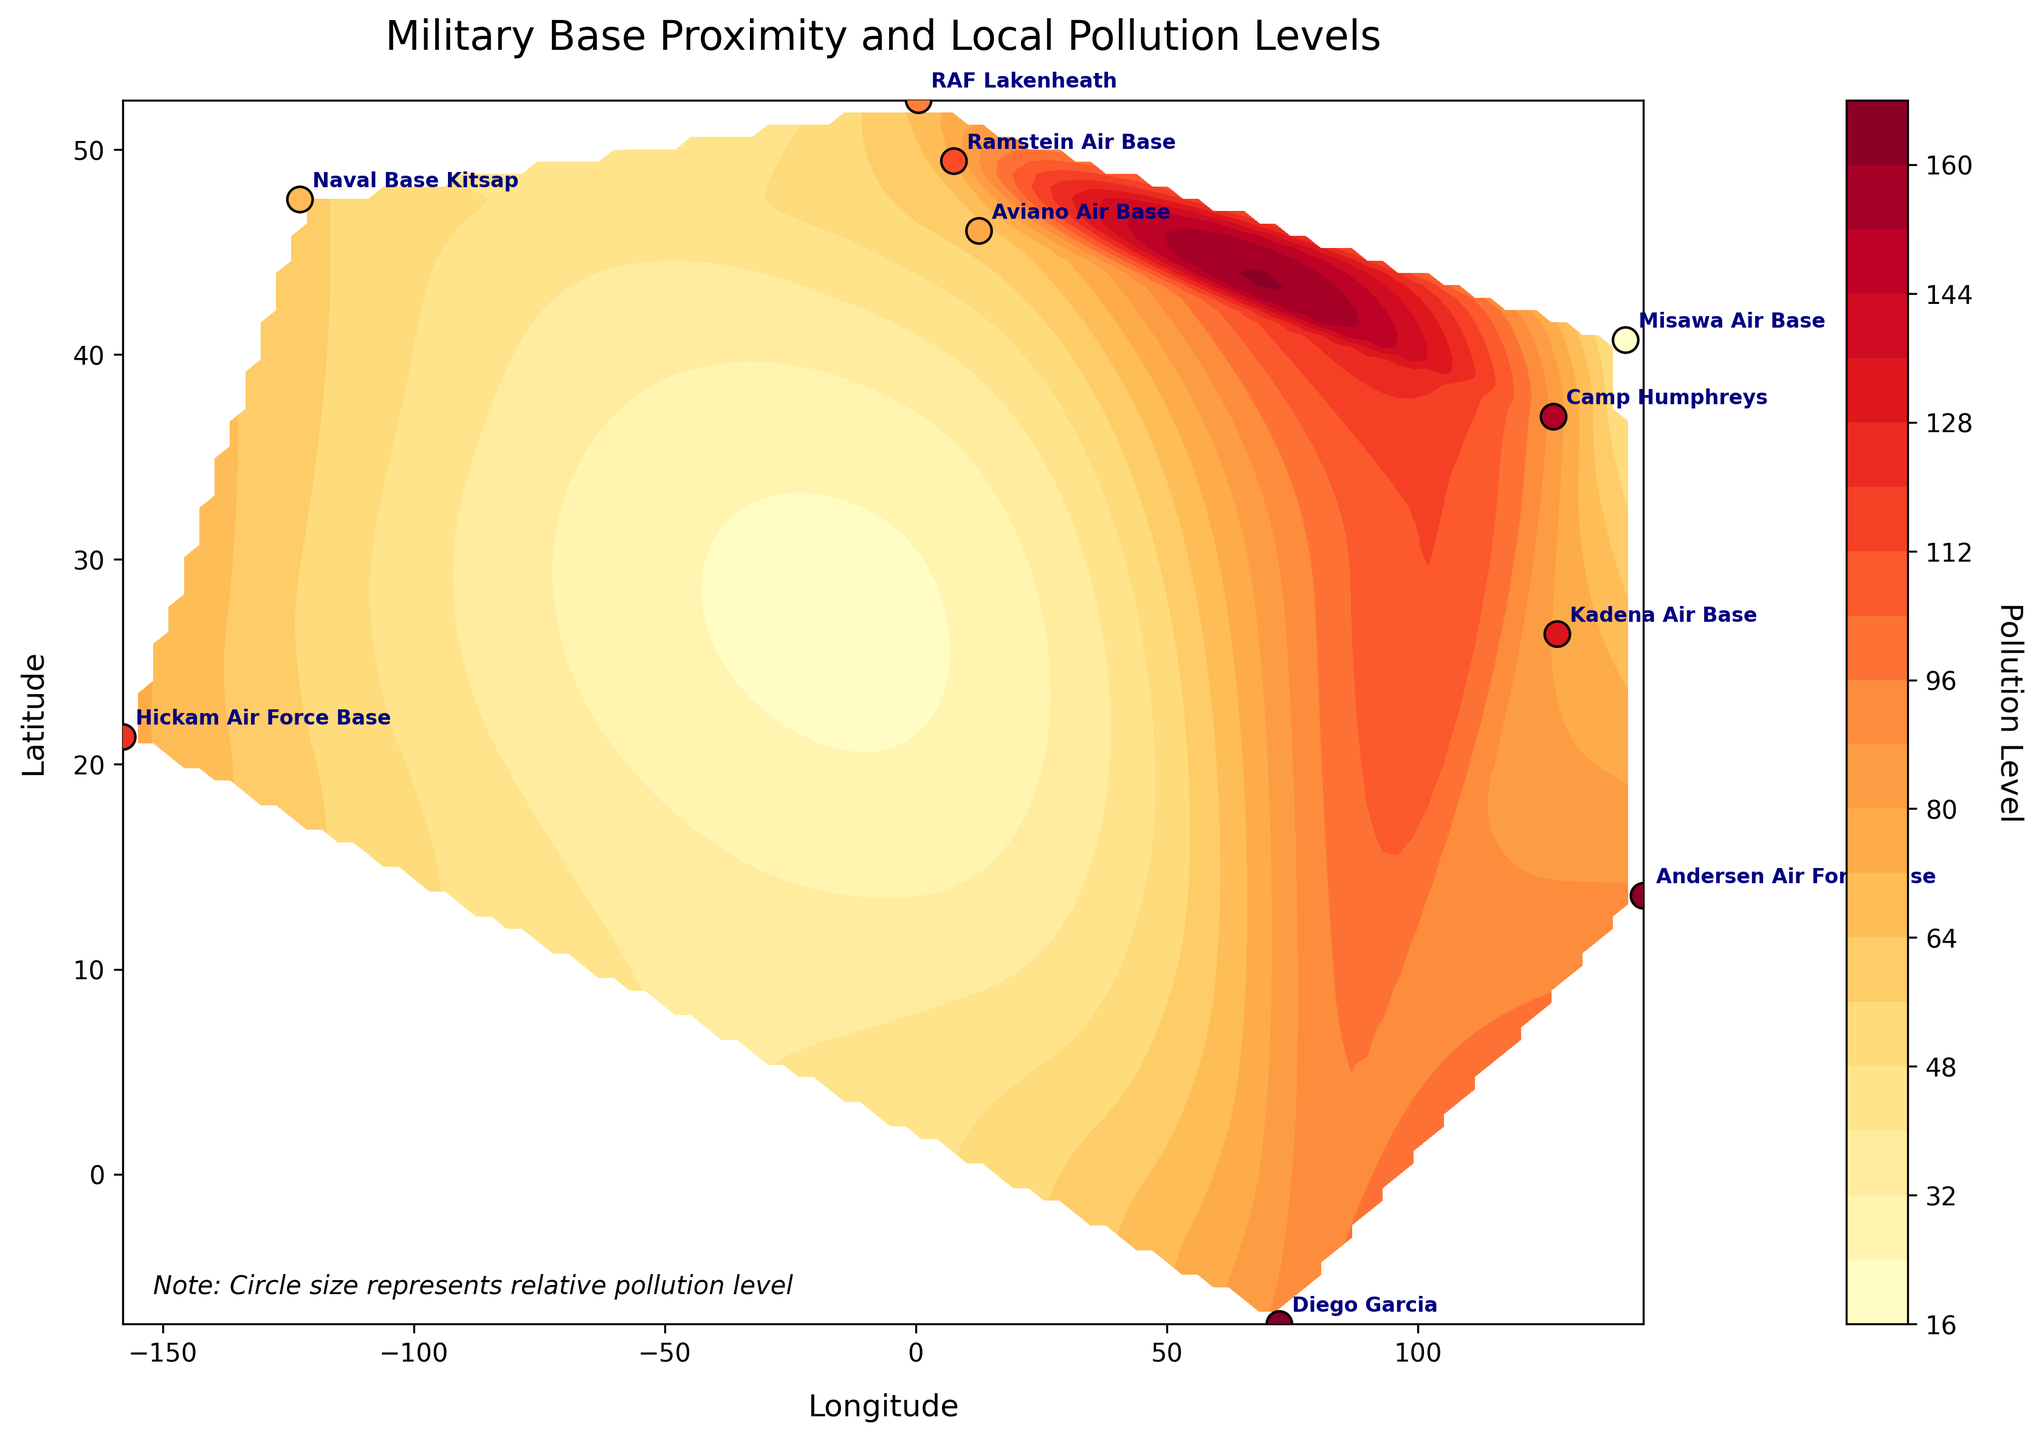Which country has the highest pollution level? From the figure, identify the country corresponding to the highest pollution level indicated on the color bar and scatter plot annotations. The highest pollution level is represented by the darkest color. The base in Diego Garcia, UK, has a pollution level of 90.
Answer: UK Which military base has the lowest pollution level? Examine the scatter plot for the dots and their color intensity, which represent different pollution levels. The base labeled Misawa Air Base, Japan, has the lightest color, indicating the lowest pollution level of 41.
Answer: Misawa Air Base, Japan What is the average pollution level for the military bases in Japan? Identify the bases in Japan (Misawa Air Base with 41 and Kadena Air Base with 79), sum their pollution levels (41 + 79 = 120), and divide by the number of bases (120 / 2 = 60).
Answer: 60 Are the pollution levels at US bases generally higher or lower than at UK bases? Compare the average pollution levels of US bases (Naval Base Kitsap with 58, Hickam AFB with 75) and UK bases (RAF Lakenheath with 67, Diego Garcia with 90). (58 + 75) / 2 = 66.5; (67 + 90) / 2 = 78.5. So on average, UK bases have higher pollution levels.
Answer: Higher Which base is located at the northernmost latitude? Look at the y-axis (latitude) and find the base that is located at the highest point. Ramstein Air Base, Germany, is located at the northernmost latitude of 49.4369.
Answer: Ramstein Air Base, Germany What type of relationship can be inferred from the contour lines between proximity to multiple military bases and pollution levels? Analyze the shape and gradient of the contour lines. Closely spaced contours indicate steep pollution gradients, implying higher pollution near military base proximities, whereas broadly spaced contours indicate lower gradients. Central regions of the contours generally indicate higher pollution levels.
Answer: Higher pollution near military bases How does the pollution level at Andersen Air Force Base compare to that at Camp Humphreys? Check the annotated labels and color intensities of these two bases. Andersen Air Force Base has a pollution level of 89, while Camp Humphreys has 85, making Andersen slightly higher.
Answer: Andersen AFB is higher Is there a significant difference in the pollution levels between bases in eastern Asia and those in Europe? Compare the average pollution levels of bases in eastern Asia (Camp Humphreys, Misawa, Kadena with 85, 41, 79 respectively = (85+41+79)/3=68.33) and bases in Europe (Ramstein, Aviano, RAF Lakenheath = 72+61+67=66.67). The averages indicate only a slight difference.
Answer: No significant difference Which base is closest to the equator and what is its pollution level? Find the base with the latitude value closest to 0 on the y-axis. Diego Garcia, UK, located at -7.3133 latitude, has a pollution level of 90.
Answer: Diego Garcia, 90 